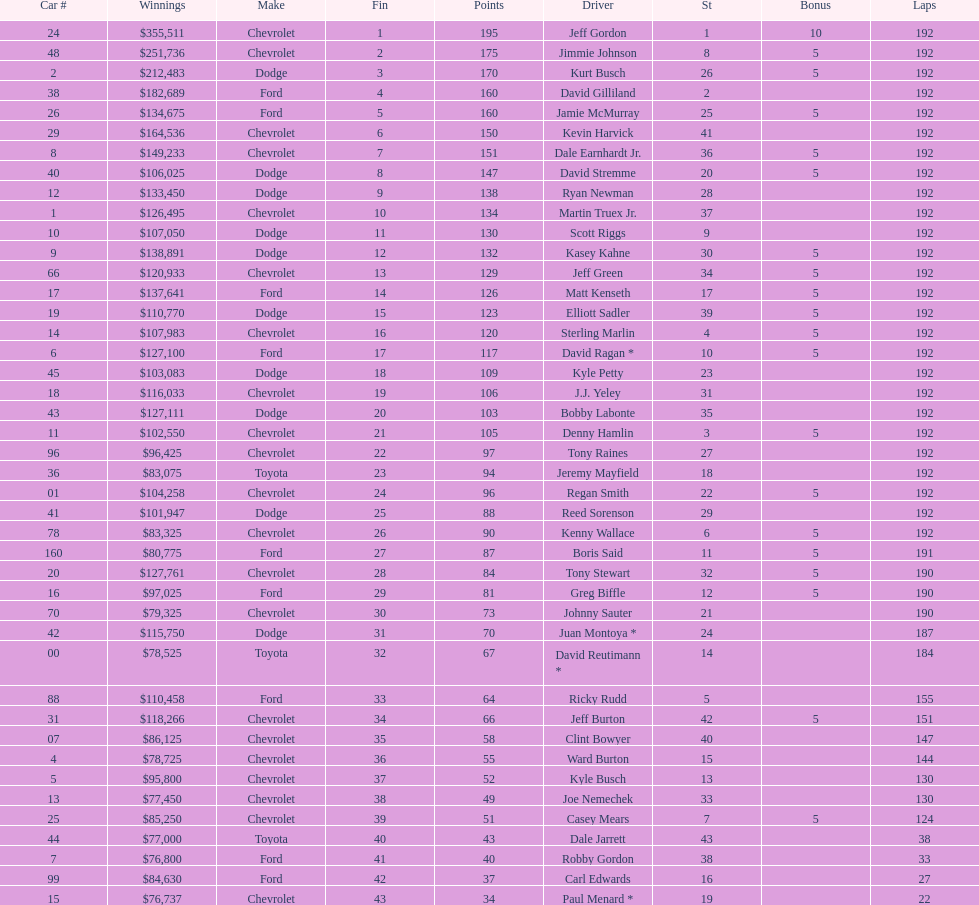Could you parse the entire table as a dict? {'header': ['Car #', 'Winnings', 'Make', 'Fin', 'Points', 'Driver', 'St', 'Bonus', 'Laps'], 'rows': [['24', '$355,511', 'Chevrolet', '1', '195', 'Jeff Gordon', '1', '10', '192'], ['48', '$251,736', 'Chevrolet', '2', '175', 'Jimmie Johnson', '8', '5', '192'], ['2', '$212,483', 'Dodge', '3', '170', 'Kurt Busch', '26', '5', '192'], ['38', '$182,689', 'Ford', '4', '160', 'David Gilliland', '2', '', '192'], ['26', '$134,675', 'Ford', '5', '160', 'Jamie McMurray', '25', '5', '192'], ['29', '$164,536', 'Chevrolet', '6', '150', 'Kevin Harvick', '41', '', '192'], ['8', '$149,233', 'Chevrolet', '7', '151', 'Dale Earnhardt Jr.', '36', '5', '192'], ['40', '$106,025', 'Dodge', '8', '147', 'David Stremme', '20', '5', '192'], ['12', '$133,450', 'Dodge', '9', '138', 'Ryan Newman', '28', '', '192'], ['1', '$126,495', 'Chevrolet', '10', '134', 'Martin Truex Jr.', '37', '', '192'], ['10', '$107,050', 'Dodge', '11', '130', 'Scott Riggs', '9', '', '192'], ['9', '$138,891', 'Dodge', '12', '132', 'Kasey Kahne', '30', '5', '192'], ['66', '$120,933', 'Chevrolet', '13', '129', 'Jeff Green', '34', '5', '192'], ['17', '$137,641', 'Ford', '14', '126', 'Matt Kenseth', '17', '5', '192'], ['19', '$110,770', 'Dodge', '15', '123', 'Elliott Sadler', '39', '5', '192'], ['14', '$107,983', 'Chevrolet', '16', '120', 'Sterling Marlin', '4', '5', '192'], ['6', '$127,100', 'Ford', '17', '117', 'David Ragan *', '10', '5', '192'], ['45', '$103,083', 'Dodge', '18', '109', 'Kyle Petty', '23', '', '192'], ['18', '$116,033', 'Chevrolet', '19', '106', 'J.J. Yeley', '31', '', '192'], ['43', '$127,111', 'Dodge', '20', '103', 'Bobby Labonte', '35', '', '192'], ['11', '$102,550', 'Chevrolet', '21', '105', 'Denny Hamlin', '3', '5', '192'], ['96', '$96,425', 'Chevrolet', '22', '97', 'Tony Raines', '27', '', '192'], ['36', '$83,075', 'Toyota', '23', '94', 'Jeremy Mayfield', '18', '', '192'], ['01', '$104,258', 'Chevrolet', '24', '96', 'Regan Smith', '22', '5', '192'], ['41', '$101,947', 'Dodge', '25', '88', 'Reed Sorenson', '29', '', '192'], ['78', '$83,325', 'Chevrolet', '26', '90', 'Kenny Wallace', '6', '5', '192'], ['160', '$80,775', 'Ford', '27', '87', 'Boris Said', '11', '5', '191'], ['20', '$127,761', 'Chevrolet', '28', '84', 'Tony Stewart', '32', '5', '190'], ['16', '$97,025', 'Ford', '29', '81', 'Greg Biffle', '12', '5', '190'], ['70', '$79,325', 'Chevrolet', '30', '73', 'Johnny Sauter', '21', '', '190'], ['42', '$115,750', 'Dodge', '31', '70', 'Juan Montoya *', '24', '', '187'], ['00', '$78,525', 'Toyota', '32', '67', 'David Reutimann *', '14', '', '184'], ['88', '$110,458', 'Ford', '33', '64', 'Ricky Rudd', '5', '', '155'], ['31', '$118,266', 'Chevrolet', '34', '66', 'Jeff Burton', '42', '5', '151'], ['07', '$86,125', 'Chevrolet', '35', '58', 'Clint Bowyer', '40', '', '147'], ['4', '$78,725', 'Chevrolet', '36', '55', 'Ward Burton', '15', '', '144'], ['5', '$95,800', 'Chevrolet', '37', '52', 'Kyle Busch', '13', '', '130'], ['13', '$77,450', 'Chevrolet', '38', '49', 'Joe Nemechek', '33', '', '130'], ['25', '$85,250', 'Chevrolet', '39', '51', 'Casey Mears', '7', '5', '124'], ['44', '$77,000', 'Toyota', '40', '43', 'Dale Jarrett', '43', '', '38'], ['7', '$76,800', 'Ford', '41', '40', 'Robby Gordon', '38', '', '33'], ['99', '$84,630', 'Ford', '42', '37', 'Carl Edwards', '16', '', '27'], ['15', '$76,737', 'Chevrolet', '43', '34', 'Paul Menard *', '19', '', '22']]} What was the make of both jeff gordon's and jimmie johnson's race car? Chevrolet. 